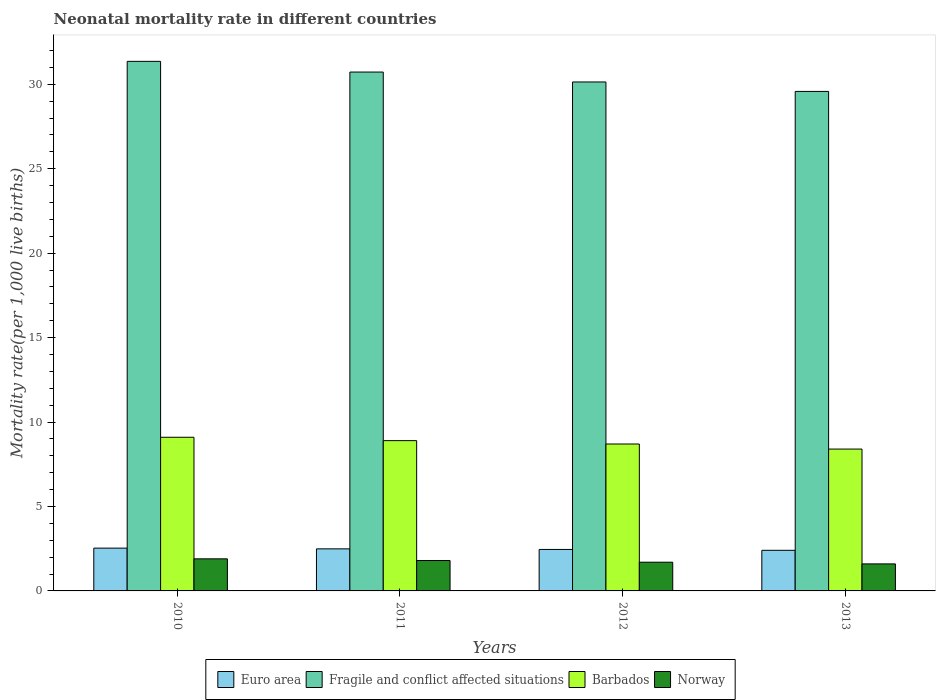Are the number of bars on each tick of the X-axis equal?
Provide a short and direct response. Yes. What is the label of the 2nd group of bars from the left?
Your response must be concise. 2011. What is the neonatal mortality rate in Barbados in 2010?
Your answer should be compact. 9.1. In which year was the neonatal mortality rate in Fragile and conflict affected situations maximum?
Provide a succinct answer. 2010. In which year was the neonatal mortality rate in Fragile and conflict affected situations minimum?
Give a very brief answer. 2013. What is the total neonatal mortality rate in Euro area in the graph?
Offer a very short reply. 9.89. What is the difference between the neonatal mortality rate in Norway in 2010 and that in 2012?
Provide a succinct answer. 0.2. What is the difference between the neonatal mortality rate in Barbados in 2010 and the neonatal mortality rate in Euro area in 2013?
Ensure brevity in your answer.  6.69. What is the average neonatal mortality rate in Fragile and conflict affected situations per year?
Offer a very short reply. 30.45. In the year 2011, what is the difference between the neonatal mortality rate in Barbados and neonatal mortality rate in Euro area?
Ensure brevity in your answer.  6.41. In how many years, is the neonatal mortality rate in Norway greater than 22?
Offer a terse response. 0. What is the ratio of the neonatal mortality rate in Barbados in 2011 to that in 2013?
Offer a very short reply. 1.06. Is the neonatal mortality rate in Euro area in 2012 less than that in 2013?
Your response must be concise. No. Is the difference between the neonatal mortality rate in Barbados in 2012 and 2013 greater than the difference between the neonatal mortality rate in Euro area in 2012 and 2013?
Give a very brief answer. Yes. What is the difference between the highest and the second highest neonatal mortality rate in Norway?
Your answer should be compact. 0.1. What is the difference between the highest and the lowest neonatal mortality rate in Fragile and conflict affected situations?
Give a very brief answer. 1.78. In how many years, is the neonatal mortality rate in Euro area greater than the average neonatal mortality rate in Euro area taken over all years?
Your answer should be compact. 2. Is it the case that in every year, the sum of the neonatal mortality rate in Norway and neonatal mortality rate in Barbados is greater than the sum of neonatal mortality rate in Euro area and neonatal mortality rate in Fragile and conflict affected situations?
Ensure brevity in your answer.  Yes. What does the 2nd bar from the left in 2013 represents?
Your answer should be compact. Fragile and conflict affected situations. What does the 3rd bar from the right in 2011 represents?
Ensure brevity in your answer.  Fragile and conflict affected situations. How many years are there in the graph?
Your answer should be compact. 4. What is the difference between two consecutive major ticks on the Y-axis?
Your answer should be very brief. 5. Are the values on the major ticks of Y-axis written in scientific E-notation?
Offer a terse response. No. Does the graph contain any zero values?
Give a very brief answer. No. Does the graph contain grids?
Offer a terse response. No. Where does the legend appear in the graph?
Provide a succinct answer. Bottom center. What is the title of the graph?
Provide a succinct answer. Neonatal mortality rate in different countries. Does "Nepal" appear as one of the legend labels in the graph?
Provide a short and direct response. No. What is the label or title of the X-axis?
Your response must be concise. Years. What is the label or title of the Y-axis?
Offer a very short reply. Mortality rate(per 1,0 live births). What is the Mortality rate(per 1,000 live births) of Euro area in 2010?
Your response must be concise. 2.53. What is the Mortality rate(per 1,000 live births) in Fragile and conflict affected situations in 2010?
Keep it short and to the point. 31.36. What is the Mortality rate(per 1,000 live births) of Norway in 2010?
Provide a short and direct response. 1.9. What is the Mortality rate(per 1,000 live births) in Euro area in 2011?
Keep it short and to the point. 2.49. What is the Mortality rate(per 1,000 live births) of Fragile and conflict affected situations in 2011?
Your answer should be compact. 30.73. What is the Mortality rate(per 1,000 live births) of Euro area in 2012?
Your answer should be very brief. 2.46. What is the Mortality rate(per 1,000 live births) of Fragile and conflict affected situations in 2012?
Your answer should be very brief. 30.14. What is the Mortality rate(per 1,000 live births) of Norway in 2012?
Ensure brevity in your answer.  1.7. What is the Mortality rate(per 1,000 live births) of Euro area in 2013?
Give a very brief answer. 2.41. What is the Mortality rate(per 1,000 live births) of Fragile and conflict affected situations in 2013?
Ensure brevity in your answer.  29.58. What is the Mortality rate(per 1,000 live births) in Barbados in 2013?
Ensure brevity in your answer.  8.4. Across all years, what is the maximum Mortality rate(per 1,000 live births) of Euro area?
Make the answer very short. 2.53. Across all years, what is the maximum Mortality rate(per 1,000 live births) in Fragile and conflict affected situations?
Offer a terse response. 31.36. Across all years, what is the maximum Mortality rate(per 1,000 live births) in Barbados?
Offer a very short reply. 9.1. Across all years, what is the minimum Mortality rate(per 1,000 live births) of Euro area?
Make the answer very short. 2.41. Across all years, what is the minimum Mortality rate(per 1,000 live births) in Fragile and conflict affected situations?
Offer a very short reply. 29.58. Across all years, what is the minimum Mortality rate(per 1,000 live births) in Norway?
Your response must be concise. 1.6. What is the total Mortality rate(per 1,000 live births) in Euro area in the graph?
Your answer should be compact. 9.89. What is the total Mortality rate(per 1,000 live births) in Fragile and conflict affected situations in the graph?
Offer a very short reply. 121.81. What is the total Mortality rate(per 1,000 live births) in Barbados in the graph?
Offer a very short reply. 35.1. What is the difference between the Mortality rate(per 1,000 live births) in Euro area in 2010 and that in 2011?
Ensure brevity in your answer.  0.04. What is the difference between the Mortality rate(per 1,000 live births) of Fragile and conflict affected situations in 2010 and that in 2011?
Your answer should be very brief. 0.63. What is the difference between the Mortality rate(per 1,000 live births) in Barbados in 2010 and that in 2011?
Offer a very short reply. 0.2. What is the difference between the Mortality rate(per 1,000 live births) in Euro area in 2010 and that in 2012?
Provide a short and direct response. 0.08. What is the difference between the Mortality rate(per 1,000 live births) of Fragile and conflict affected situations in 2010 and that in 2012?
Give a very brief answer. 1.22. What is the difference between the Mortality rate(per 1,000 live births) in Norway in 2010 and that in 2012?
Ensure brevity in your answer.  0.2. What is the difference between the Mortality rate(per 1,000 live births) of Euro area in 2010 and that in 2013?
Your answer should be compact. 0.13. What is the difference between the Mortality rate(per 1,000 live births) in Fragile and conflict affected situations in 2010 and that in 2013?
Provide a short and direct response. 1.78. What is the difference between the Mortality rate(per 1,000 live births) of Norway in 2010 and that in 2013?
Provide a short and direct response. 0.3. What is the difference between the Mortality rate(per 1,000 live births) in Euro area in 2011 and that in 2012?
Offer a very short reply. 0.04. What is the difference between the Mortality rate(per 1,000 live births) of Fragile and conflict affected situations in 2011 and that in 2012?
Give a very brief answer. 0.59. What is the difference between the Mortality rate(per 1,000 live births) in Barbados in 2011 and that in 2012?
Your answer should be very brief. 0.2. What is the difference between the Mortality rate(per 1,000 live births) in Euro area in 2011 and that in 2013?
Ensure brevity in your answer.  0.09. What is the difference between the Mortality rate(per 1,000 live births) in Fragile and conflict affected situations in 2011 and that in 2013?
Your response must be concise. 1.15. What is the difference between the Mortality rate(per 1,000 live births) in Euro area in 2012 and that in 2013?
Provide a short and direct response. 0.05. What is the difference between the Mortality rate(per 1,000 live births) of Fragile and conflict affected situations in 2012 and that in 2013?
Offer a very short reply. 0.56. What is the difference between the Mortality rate(per 1,000 live births) in Barbados in 2012 and that in 2013?
Your answer should be very brief. 0.3. What is the difference between the Mortality rate(per 1,000 live births) in Norway in 2012 and that in 2013?
Provide a short and direct response. 0.1. What is the difference between the Mortality rate(per 1,000 live births) of Euro area in 2010 and the Mortality rate(per 1,000 live births) of Fragile and conflict affected situations in 2011?
Your answer should be compact. -28.19. What is the difference between the Mortality rate(per 1,000 live births) of Euro area in 2010 and the Mortality rate(per 1,000 live births) of Barbados in 2011?
Keep it short and to the point. -6.37. What is the difference between the Mortality rate(per 1,000 live births) in Euro area in 2010 and the Mortality rate(per 1,000 live births) in Norway in 2011?
Your answer should be compact. 0.73. What is the difference between the Mortality rate(per 1,000 live births) of Fragile and conflict affected situations in 2010 and the Mortality rate(per 1,000 live births) of Barbados in 2011?
Your answer should be compact. 22.46. What is the difference between the Mortality rate(per 1,000 live births) in Fragile and conflict affected situations in 2010 and the Mortality rate(per 1,000 live births) in Norway in 2011?
Provide a short and direct response. 29.56. What is the difference between the Mortality rate(per 1,000 live births) of Barbados in 2010 and the Mortality rate(per 1,000 live births) of Norway in 2011?
Keep it short and to the point. 7.3. What is the difference between the Mortality rate(per 1,000 live births) of Euro area in 2010 and the Mortality rate(per 1,000 live births) of Fragile and conflict affected situations in 2012?
Ensure brevity in your answer.  -27.61. What is the difference between the Mortality rate(per 1,000 live births) of Euro area in 2010 and the Mortality rate(per 1,000 live births) of Barbados in 2012?
Provide a short and direct response. -6.17. What is the difference between the Mortality rate(per 1,000 live births) in Euro area in 2010 and the Mortality rate(per 1,000 live births) in Norway in 2012?
Offer a terse response. 0.83. What is the difference between the Mortality rate(per 1,000 live births) of Fragile and conflict affected situations in 2010 and the Mortality rate(per 1,000 live births) of Barbados in 2012?
Your answer should be very brief. 22.66. What is the difference between the Mortality rate(per 1,000 live births) in Fragile and conflict affected situations in 2010 and the Mortality rate(per 1,000 live births) in Norway in 2012?
Give a very brief answer. 29.66. What is the difference between the Mortality rate(per 1,000 live births) in Euro area in 2010 and the Mortality rate(per 1,000 live births) in Fragile and conflict affected situations in 2013?
Provide a succinct answer. -27.05. What is the difference between the Mortality rate(per 1,000 live births) in Euro area in 2010 and the Mortality rate(per 1,000 live births) in Barbados in 2013?
Your answer should be compact. -5.87. What is the difference between the Mortality rate(per 1,000 live births) of Euro area in 2010 and the Mortality rate(per 1,000 live births) of Norway in 2013?
Make the answer very short. 0.93. What is the difference between the Mortality rate(per 1,000 live births) in Fragile and conflict affected situations in 2010 and the Mortality rate(per 1,000 live births) in Barbados in 2013?
Offer a very short reply. 22.96. What is the difference between the Mortality rate(per 1,000 live births) of Fragile and conflict affected situations in 2010 and the Mortality rate(per 1,000 live births) of Norway in 2013?
Give a very brief answer. 29.76. What is the difference between the Mortality rate(per 1,000 live births) of Barbados in 2010 and the Mortality rate(per 1,000 live births) of Norway in 2013?
Your answer should be very brief. 7.5. What is the difference between the Mortality rate(per 1,000 live births) in Euro area in 2011 and the Mortality rate(per 1,000 live births) in Fragile and conflict affected situations in 2012?
Give a very brief answer. -27.65. What is the difference between the Mortality rate(per 1,000 live births) in Euro area in 2011 and the Mortality rate(per 1,000 live births) in Barbados in 2012?
Give a very brief answer. -6.21. What is the difference between the Mortality rate(per 1,000 live births) of Euro area in 2011 and the Mortality rate(per 1,000 live births) of Norway in 2012?
Your answer should be compact. 0.79. What is the difference between the Mortality rate(per 1,000 live births) in Fragile and conflict affected situations in 2011 and the Mortality rate(per 1,000 live births) in Barbados in 2012?
Your answer should be compact. 22.03. What is the difference between the Mortality rate(per 1,000 live births) in Fragile and conflict affected situations in 2011 and the Mortality rate(per 1,000 live births) in Norway in 2012?
Offer a very short reply. 29.03. What is the difference between the Mortality rate(per 1,000 live births) in Euro area in 2011 and the Mortality rate(per 1,000 live births) in Fragile and conflict affected situations in 2013?
Offer a terse response. -27.09. What is the difference between the Mortality rate(per 1,000 live births) of Euro area in 2011 and the Mortality rate(per 1,000 live births) of Barbados in 2013?
Provide a short and direct response. -5.91. What is the difference between the Mortality rate(per 1,000 live births) in Euro area in 2011 and the Mortality rate(per 1,000 live births) in Norway in 2013?
Offer a terse response. 0.89. What is the difference between the Mortality rate(per 1,000 live births) of Fragile and conflict affected situations in 2011 and the Mortality rate(per 1,000 live births) of Barbados in 2013?
Your answer should be very brief. 22.33. What is the difference between the Mortality rate(per 1,000 live births) of Fragile and conflict affected situations in 2011 and the Mortality rate(per 1,000 live births) of Norway in 2013?
Offer a very short reply. 29.13. What is the difference between the Mortality rate(per 1,000 live births) of Euro area in 2012 and the Mortality rate(per 1,000 live births) of Fragile and conflict affected situations in 2013?
Offer a terse response. -27.12. What is the difference between the Mortality rate(per 1,000 live births) in Euro area in 2012 and the Mortality rate(per 1,000 live births) in Barbados in 2013?
Make the answer very short. -5.94. What is the difference between the Mortality rate(per 1,000 live births) in Euro area in 2012 and the Mortality rate(per 1,000 live births) in Norway in 2013?
Provide a short and direct response. 0.86. What is the difference between the Mortality rate(per 1,000 live births) in Fragile and conflict affected situations in 2012 and the Mortality rate(per 1,000 live births) in Barbados in 2013?
Ensure brevity in your answer.  21.74. What is the difference between the Mortality rate(per 1,000 live births) in Fragile and conflict affected situations in 2012 and the Mortality rate(per 1,000 live births) in Norway in 2013?
Offer a very short reply. 28.54. What is the average Mortality rate(per 1,000 live births) of Euro area per year?
Your answer should be very brief. 2.47. What is the average Mortality rate(per 1,000 live births) in Fragile and conflict affected situations per year?
Make the answer very short. 30.45. What is the average Mortality rate(per 1,000 live births) in Barbados per year?
Offer a terse response. 8.78. What is the average Mortality rate(per 1,000 live births) in Norway per year?
Offer a terse response. 1.75. In the year 2010, what is the difference between the Mortality rate(per 1,000 live births) of Euro area and Mortality rate(per 1,000 live births) of Fragile and conflict affected situations?
Give a very brief answer. -28.83. In the year 2010, what is the difference between the Mortality rate(per 1,000 live births) of Euro area and Mortality rate(per 1,000 live births) of Barbados?
Provide a succinct answer. -6.57. In the year 2010, what is the difference between the Mortality rate(per 1,000 live births) of Euro area and Mortality rate(per 1,000 live births) of Norway?
Give a very brief answer. 0.63. In the year 2010, what is the difference between the Mortality rate(per 1,000 live births) in Fragile and conflict affected situations and Mortality rate(per 1,000 live births) in Barbados?
Give a very brief answer. 22.26. In the year 2010, what is the difference between the Mortality rate(per 1,000 live births) of Fragile and conflict affected situations and Mortality rate(per 1,000 live births) of Norway?
Make the answer very short. 29.46. In the year 2010, what is the difference between the Mortality rate(per 1,000 live births) of Barbados and Mortality rate(per 1,000 live births) of Norway?
Your answer should be very brief. 7.2. In the year 2011, what is the difference between the Mortality rate(per 1,000 live births) of Euro area and Mortality rate(per 1,000 live births) of Fragile and conflict affected situations?
Provide a succinct answer. -28.24. In the year 2011, what is the difference between the Mortality rate(per 1,000 live births) of Euro area and Mortality rate(per 1,000 live births) of Barbados?
Ensure brevity in your answer.  -6.41. In the year 2011, what is the difference between the Mortality rate(per 1,000 live births) in Euro area and Mortality rate(per 1,000 live births) in Norway?
Your answer should be very brief. 0.69. In the year 2011, what is the difference between the Mortality rate(per 1,000 live births) in Fragile and conflict affected situations and Mortality rate(per 1,000 live births) in Barbados?
Your answer should be compact. 21.83. In the year 2011, what is the difference between the Mortality rate(per 1,000 live births) of Fragile and conflict affected situations and Mortality rate(per 1,000 live births) of Norway?
Ensure brevity in your answer.  28.93. In the year 2011, what is the difference between the Mortality rate(per 1,000 live births) of Barbados and Mortality rate(per 1,000 live births) of Norway?
Offer a terse response. 7.1. In the year 2012, what is the difference between the Mortality rate(per 1,000 live births) in Euro area and Mortality rate(per 1,000 live births) in Fragile and conflict affected situations?
Your response must be concise. -27.68. In the year 2012, what is the difference between the Mortality rate(per 1,000 live births) in Euro area and Mortality rate(per 1,000 live births) in Barbados?
Keep it short and to the point. -6.24. In the year 2012, what is the difference between the Mortality rate(per 1,000 live births) in Euro area and Mortality rate(per 1,000 live births) in Norway?
Offer a terse response. 0.76. In the year 2012, what is the difference between the Mortality rate(per 1,000 live births) of Fragile and conflict affected situations and Mortality rate(per 1,000 live births) of Barbados?
Your response must be concise. 21.44. In the year 2012, what is the difference between the Mortality rate(per 1,000 live births) of Fragile and conflict affected situations and Mortality rate(per 1,000 live births) of Norway?
Provide a short and direct response. 28.44. In the year 2012, what is the difference between the Mortality rate(per 1,000 live births) of Barbados and Mortality rate(per 1,000 live births) of Norway?
Keep it short and to the point. 7. In the year 2013, what is the difference between the Mortality rate(per 1,000 live births) in Euro area and Mortality rate(per 1,000 live births) in Fragile and conflict affected situations?
Provide a short and direct response. -27.17. In the year 2013, what is the difference between the Mortality rate(per 1,000 live births) in Euro area and Mortality rate(per 1,000 live births) in Barbados?
Provide a short and direct response. -5.99. In the year 2013, what is the difference between the Mortality rate(per 1,000 live births) in Euro area and Mortality rate(per 1,000 live births) in Norway?
Provide a succinct answer. 0.81. In the year 2013, what is the difference between the Mortality rate(per 1,000 live births) of Fragile and conflict affected situations and Mortality rate(per 1,000 live births) of Barbados?
Ensure brevity in your answer.  21.18. In the year 2013, what is the difference between the Mortality rate(per 1,000 live births) of Fragile and conflict affected situations and Mortality rate(per 1,000 live births) of Norway?
Provide a short and direct response. 27.98. In the year 2013, what is the difference between the Mortality rate(per 1,000 live births) in Barbados and Mortality rate(per 1,000 live births) in Norway?
Your answer should be very brief. 6.8. What is the ratio of the Mortality rate(per 1,000 live births) in Euro area in 2010 to that in 2011?
Offer a terse response. 1.02. What is the ratio of the Mortality rate(per 1,000 live births) of Fragile and conflict affected situations in 2010 to that in 2011?
Provide a succinct answer. 1.02. What is the ratio of the Mortality rate(per 1,000 live births) in Barbados in 2010 to that in 2011?
Your answer should be very brief. 1.02. What is the ratio of the Mortality rate(per 1,000 live births) of Norway in 2010 to that in 2011?
Make the answer very short. 1.06. What is the ratio of the Mortality rate(per 1,000 live births) of Euro area in 2010 to that in 2012?
Keep it short and to the point. 1.03. What is the ratio of the Mortality rate(per 1,000 live births) of Fragile and conflict affected situations in 2010 to that in 2012?
Provide a succinct answer. 1.04. What is the ratio of the Mortality rate(per 1,000 live births) of Barbados in 2010 to that in 2012?
Provide a short and direct response. 1.05. What is the ratio of the Mortality rate(per 1,000 live births) in Norway in 2010 to that in 2012?
Make the answer very short. 1.12. What is the ratio of the Mortality rate(per 1,000 live births) in Euro area in 2010 to that in 2013?
Offer a terse response. 1.05. What is the ratio of the Mortality rate(per 1,000 live births) of Fragile and conflict affected situations in 2010 to that in 2013?
Make the answer very short. 1.06. What is the ratio of the Mortality rate(per 1,000 live births) of Norway in 2010 to that in 2013?
Offer a terse response. 1.19. What is the ratio of the Mortality rate(per 1,000 live births) in Euro area in 2011 to that in 2012?
Keep it short and to the point. 1.01. What is the ratio of the Mortality rate(per 1,000 live births) in Fragile and conflict affected situations in 2011 to that in 2012?
Provide a succinct answer. 1.02. What is the ratio of the Mortality rate(per 1,000 live births) of Barbados in 2011 to that in 2012?
Keep it short and to the point. 1.02. What is the ratio of the Mortality rate(per 1,000 live births) of Norway in 2011 to that in 2012?
Offer a very short reply. 1.06. What is the ratio of the Mortality rate(per 1,000 live births) in Euro area in 2011 to that in 2013?
Offer a terse response. 1.04. What is the ratio of the Mortality rate(per 1,000 live births) of Fragile and conflict affected situations in 2011 to that in 2013?
Provide a succinct answer. 1.04. What is the ratio of the Mortality rate(per 1,000 live births) in Barbados in 2011 to that in 2013?
Give a very brief answer. 1.06. What is the ratio of the Mortality rate(per 1,000 live births) in Norway in 2011 to that in 2013?
Offer a terse response. 1.12. What is the ratio of the Mortality rate(per 1,000 live births) of Euro area in 2012 to that in 2013?
Keep it short and to the point. 1.02. What is the ratio of the Mortality rate(per 1,000 live births) of Fragile and conflict affected situations in 2012 to that in 2013?
Keep it short and to the point. 1.02. What is the ratio of the Mortality rate(per 1,000 live births) of Barbados in 2012 to that in 2013?
Give a very brief answer. 1.04. What is the ratio of the Mortality rate(per 1,000 live births) of Norway in 2012 to that in 2013?
Ensure brevity in your answer.  1.06. What is the difference between the highest and the second highest Mortality rate(per 1,000 live births) in Euro area?
Ensure brevity in your answer.  0.04. What is the difference between the highest and the second highest Mortality rate(per 1,000 live births) of Fragile and conflict affected situations?
Offer a terse response. 0.63. What is the difference between the highest and the second highest Mortality rate(per 1,000 live births) of Norway?
Offer a very short reply. 0.1. What is the difference between the highest and the lowest Mortality rate(per 1,000 live births) of Euro area?
Offer a very short reply. 0.13. What is the difference between the highest and the lowest Mortality rate(per 1,000 live births) in Fragile and conflict affected situations?
Keep it short and to the point. 1.78. 